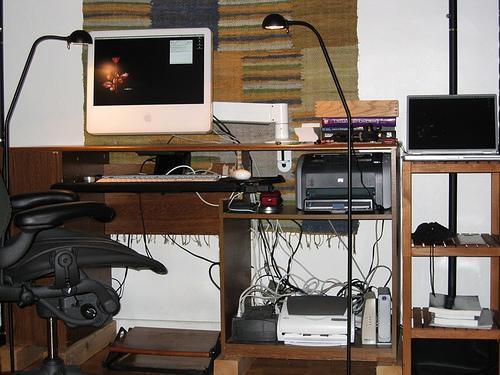How many lamps are there?
Give a very brief answer. 2. How many printers?
Give a very brief answer. 2. How many tvs are there?
Give a very brief answer. 2. How many yellow umbrellas are in this photo?
Give a very brief answer. 0. 